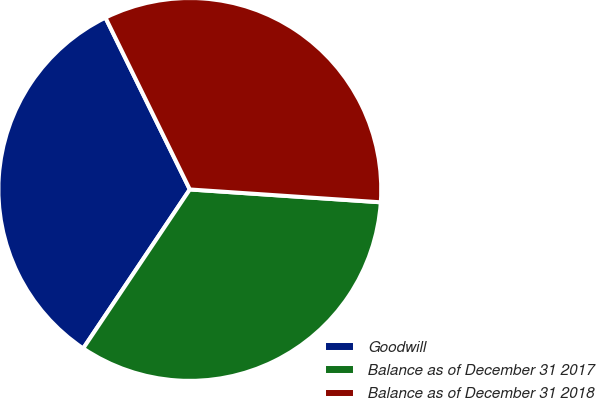<chart> <loc_0><loc_0><loc_500><loc_500><pie_chart><fcel>Goodwill<fcel>Balance as of December 31 2017<fcel>Balance as of December 31 2018<nl><fcel>33.33%<fcel>33.33%<fcel>33.33%<nl></chart> 